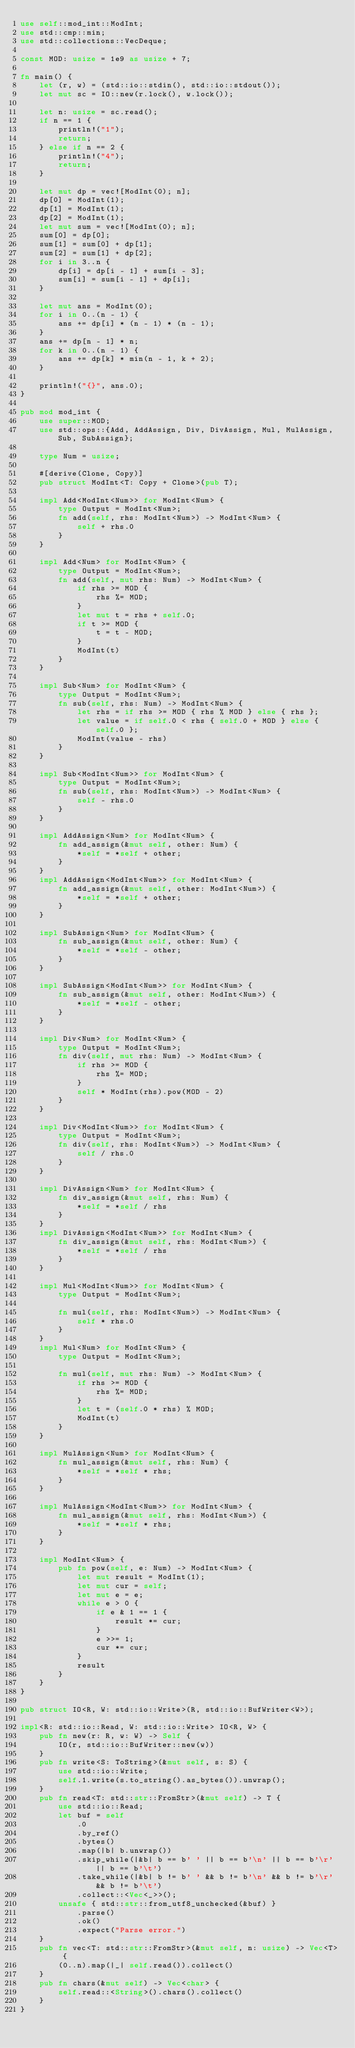<code> <loc_0><loc_0><loc_500><loc_500><_Rust_>use self::mod_int::ModInt;
use std::cmp::min;
use std::collections::VecDeque;

const MOD: usize = 1e9 as usize + 7;

fn main() {
    let (r, w) = (std::io::stdin(), std::io::stdout());
    let mut sc = IO::new(r.lock(), w.lock());

    let n: usize = sc.read();
    if n == 1 {
        println!("1");
        return;
    } else if n == 2 {
        println!("4");
        return;
    }

    let mut dp = vec![ModInt(0); n];
    dp[0] = ModInt(1);
    dp[1] = ModInt(1);
    dp[2] = ModInt(1);
    let mut sum = vec![ModInt(0); n];
    sum[0] = dp[0];
    sum[1] = sum[0] + dp[1];
    sum[2] = sum[1] + dp[2];
    for i in 3..n {
        dp[i] = dp[i - 1] + sum[i - 3];
        sum[i] = sum[i - 1] + dp[i];
    }

    let mut ans = ModInt(0);
    for i in 0..(n - 1) {
        ans += dp[i] * (n - 1) * (n - 1);
    }
    ans += dp[n - 1] * n;
    for k in 0..(n - 1) {
        ans += dp[k] * min(n - 1, k + 2);
    }

    println!("{}", ans.0);
}

pub mod mod_int {
    use super::MOD;
    use std::ops::{Add, AddAssign, Div, DivAssign, Mul, MulAssign, Sub, SubAssign};

    type Num = usize;

    #[derive(Clone, Copy)]
    pub struct ModInt<T: Copy + Clone>(pub T);

    impl Add<ModInt<Num>> for ModInt<Num> {
        type Output = ModInt<Num>;
        fn add(self, rhs: ModInt<Num>) -> ModInt<Num> {
            self + rhs.0
        }
    }

    impl Add<Num> for ModInt<Num> {
        type Output = ModInt<Num>;
        fn add(self, mut rhs: Num) -> ModInt<Num> {
            if rhs >= MOD {
                rhs %= MOD;
            }
            let mut t = rhs + self.0;
            if t >= MOD {
                t = t - MOD;
            }
            ModInt(t)
        }
    }

    impl Sub<Num> for ModInt<Num> {
        type Output = ModInt<Num>;
        fn sub(self, rhs: Num) -> ModInt<Num> {
            let rhs = if rhs >= MOD { rhs % MOD } else { rhs };
            let value = if self.0 < rhs { self.0 + MOD } else { self.0 };
            ModInt(value - rhs)
        }
    }

    impl Sub<ModInt<Num>> for ModInt<Num> {
        type Output = ModInt<Num>;
        fn sub(self, rhs: ModInt<Num>) -> ModInt<Num> {
            self - rhs.0
        }
    }

    impl AddAssign<Num> for ModInt<Num> {
        fn add_assign(&mut self, other: Num) {
            *self = *self + other;
        }
    }
    impl AddAssign<ModInt<Num>> for ModInt<Num> {
        fn add_assign(&mut self, other: ModInt<Num>) {
            *self = *self + other;
        }
    }

    impl SubAssign<Num> for ModInt<Num> {
        fn sub_assign(&mut self, other: Num) {
            *self = *self - other;
        }
    }

    impl SubAssign<ModInt<Num>> for ModInt<Num> {
        fn sub_assign(&mut self, other: ModInt<Num>) {
            *self = *self - other;
        }
    }

    impl Div<Num> for ModInt<Num> {
        type Output = ModInt<Num>;
        fn div(self, mut rhs: Num) -> ModInt<Num> {
            if rhs >= MOD {
                rhs %= MOD;
            }
            self * ModInt(rhs).pow(MOD - 2)
        }
    }

    impl Div<ModInt<Num>> for ModInt<Num> {
        type Output = ModInt<Num>;
        fn div(self, rhs: ModInt<Num>) -> ModInt<Num> {
            self / rhs.0
        }
    }

    impl DivAssign<Num> for ModInt<Num> {
        fn div_assign(&mut self, rhs: Num) {
            *self = *self / rhs
        }
    }
    impl DivAssign<ModInt<Num>> for ModInt<Num> {
        fn div_assign(&mut self, rhs: ModInt<Num>) {
            *self = *self / rhs
        }
    }

    impl Mul<ModInt<Num>> for ModInt<Num> {
        type Output = ModInt<Num>;

        fn mul(self, rhs: ModInt<Num>) -> ModInt<Num> {
            self * rhs.0
        }
    }
    impl Mul<Num> for ModInt<Num> {
        type Output = ModInt<Num>;

        fn mul(self, mut rhs: Num) -> ModInt<Num> {
            if rhs >= MOD {
                rhs %= MOD;
            }
            let t = (self.0 * rhs) % MOD;
            ModInt(t)
        }
    }

    impl MulAssign<Num> for ModInt<Num> {
        fn mul_assign(&mut self, rhs: Num) {
            *self = *self * rhs;
        }
    }

    impl MulAssign<ModInt<Num>> for ModInt<Num> {
        fn mul_assign(&mut self, rhs: ModInt<Num>) {
            *self = *self * rhs;
        }
    }

    impl ModInt<Num> {
        pub fn pow(self, e: Num) -> ModInt<Num> {
            let mut result = ModInt(1);
            let mut cur = self;
            let mut e = e;
            while e > 0 {
                if e & 1 == 1 {
                    result *= cur;
                }
                e >>= 1;
                cur *= cur;
            }
            result
        }
    }
}

pub struct IO<R, W: std::io::Write>(R, std::io::BufWriter<W>);

impl<R: std::io::Read, W: std::io::Write> IO<R, W> {
    pub fn new(r: R, w: W) -> Self {
        IO(r, std::io::BufWriter::new(w))
    }
    pub fn write<S: ToString>(&mut self, s: S) {
        use std::io::Write;
        self.1.write(s.to_string().as_bytes()).unwrap();
    }
    pub fn read<T: std::str::FromStr>(&mut self) -> T {
        use std::io::Read;
        let buf = self
            .0
            .by_ref()
            .bytes()
            .map(|b| b.unwrap())
            .skip_while(|&b| b == b' ' || b == b'\n' || b == b'\r' || b == b'\t')
            .take_while(|&b| b != b' ' && b != b'\n' && b != b'\r' && b != b'\t')
            .collect::<Vec<_>>();
        unsafe { std::str::from_utf8_unchecked(&buf) }
            .parse()
            .ok()
            .expect("Parse error.")
    }
    pub fn vec<T: std::str::FromStr>(&mut self, n: usize) -> Vec<T> {
        (0..n).map(|_| self.read()).collect()
    }
    pub fn chars(&mut self) -> Vec<char> {
        self.read::<String>().chars().collect()
    }
}
</code> 